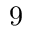<formula> <loc_0><loc_0><loc_500><loc_500>9</formula> 